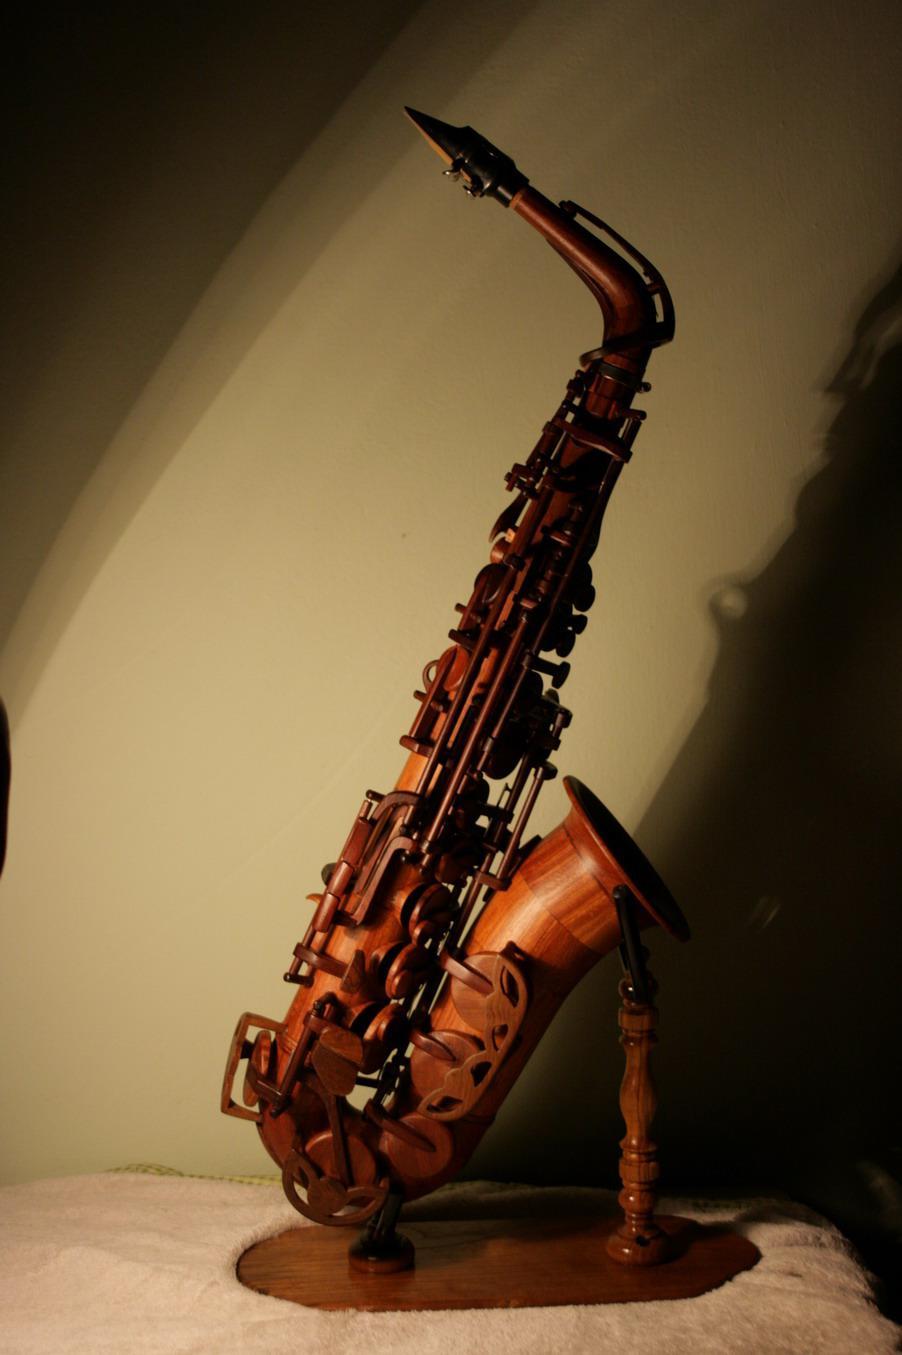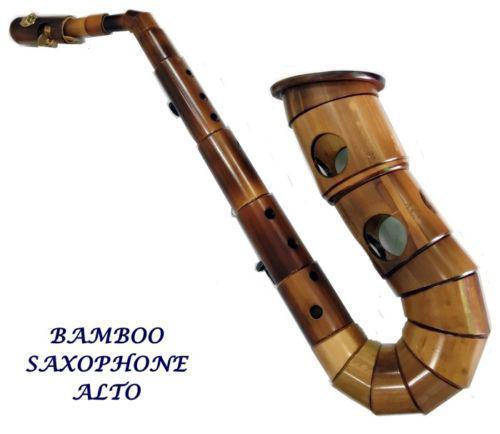The first image is the image on the left, the second image is the image on the right. For the images displayed, is the sentence "An image shows a wooden bamboo on a stand with light behind it creating deep shadow." factually correct? Answer yes or no. Yes. The first image is the image on the left, the second image is the image on the right. Examine the images to the left and right. Is the description "The saxophone in one of the images is on a stand." accurate? Answer yes or no. Yes. 